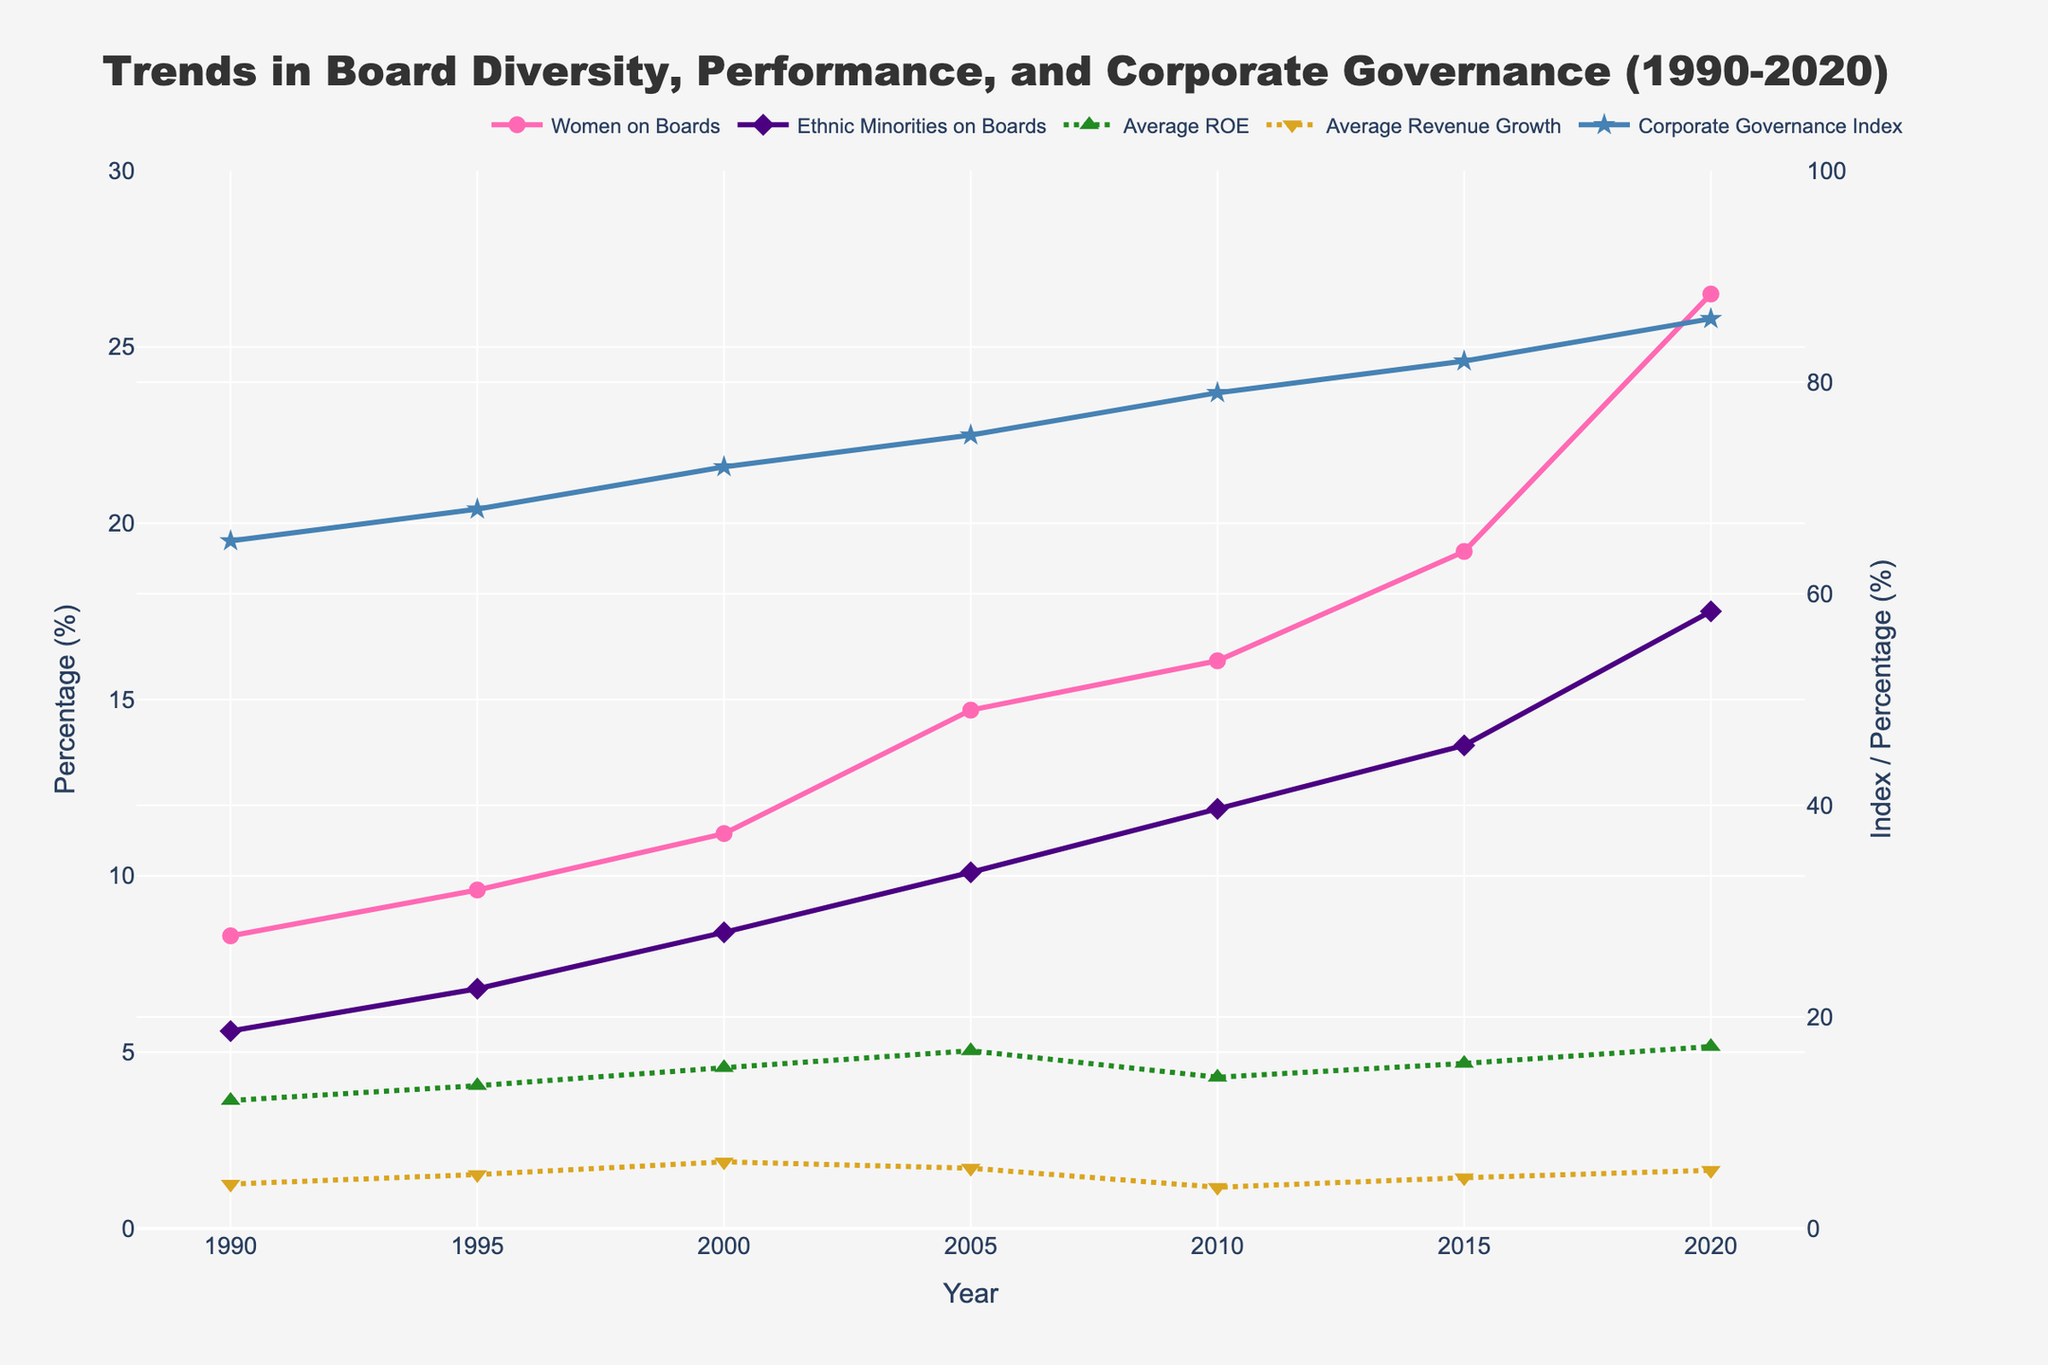How did the percentage of women on boards change from 1990 to 2020? The percentage of women on boards can be obtained by looking at the data points for the year 1990 and the year 2020 in the 'Women on Boards (%)' line. In 1990, it was 8.3%, and in 2020, it was 26.5%.
Answer: 18.2% How does the trend in board diversity compare to average ROE over the entire period? To analyze this, look at the lines representing 'Women on Boards (%)' and 'Ethnic Minorities on Boards (%)', and compare their trends to the 'Average ROE (%)' line from 1990 to 2020. Board diversity shows a consistent upward trend, while average ROE fluctuates, peaking around 2005 and then decreasing before increasing again by 2020.
Answer: Diversity increases, ROE fluctuates Between 1995 and 2005, which metric showed the largest relative increase: Women on Boards, Ethnic Minorities on Boards, Average ROE, or Average Revenue Growth? Calculate the relative increase for each metric between 1995 and 2005. For Women on Boards, it increases from 9.6% to 14.7%, Ethnic Minorities on Boards from 6.8% to 10.1%, Average ROE from 13.5% to 16.8%, and Average Revenue Growth from 5.1% to 5.7%. The largest relative increase is for Women on Boards (5.1%).
Answer: Women on Boards How does the Corporate Governance Index in 2020 compare to its value in 1990? The Corporate Governance Index for 1990 is 65, and for 2020 it is 86. The difference is 86 - 65 = 21.
Answer: Increased by 21 What was the biggest change in Average Revenue Growth (%) observed in any five-year period? Look at the data points for Average Revenue Growth to find the largest change over any consecutive five-year period: 1995 to 2000 (5.1% to 6.3%, increase of 1.2%), 2000 to 2005 (6.3% to 5.7%, decrease of 0.6%), 2005 to 2010 (5.7% to 3.9%, decrease of 1.8%), 2010 to 2015 (3.9% to 4.8%, increase of 0.9%), 2015 to 2020 (4.8% to 5.5%, increase of 0.7%). The biggest change is a decrease of 1.8% from 2005 to 2010.
Answer: Decrease of 1.8% (2005-2010) Is there a visible correlation between the Corporate Governance Index and average ROE over the time period? The Corporate Governance Index and Average ROE lines show different trends; while the Corporate Governance Index steadily increases, the Average ROE rises and falls, suggesting no clear visible correlation.
Answer: No clear correlation Which metric saw the highest absolute increase from 1990 to 2020? Calculate the absolute increase for each metric from 1990 to 2020. Women on Boards increase from 8.3% to 26.5% (an increase of 18.2%), Ethnic Minorities on Boards from 5.6% to 17.5% (an increase of 11.9%), Average ROE from 12.1% to 17.2% (an increase of 5.1%), Average Revenue Growth from 4.2% to 5.5% (an increase of 1.3%), Corporate Governance Index from 65 to 86 (an increase of 21).
Answer: Corporate Governance Index 